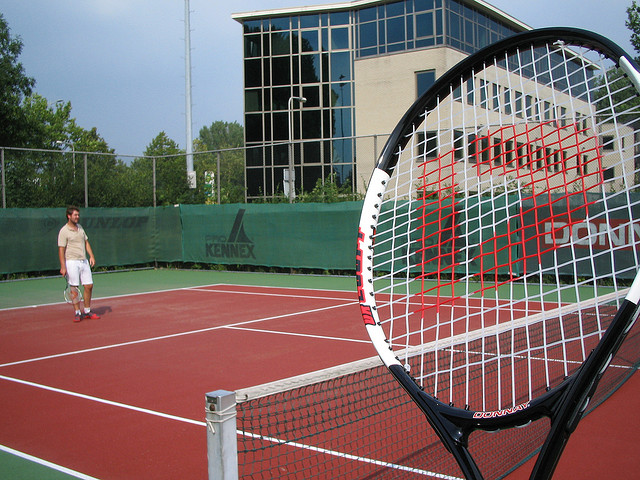<image>Who is holding the racket? It is unknown who is holding the racket. It might be the photographer, cameraman, me, man, tennis player, or picture taker. Who is holding the racket? I'm not sure who is holding the racket. It could be the photographer, the cameraman, or someone else. 